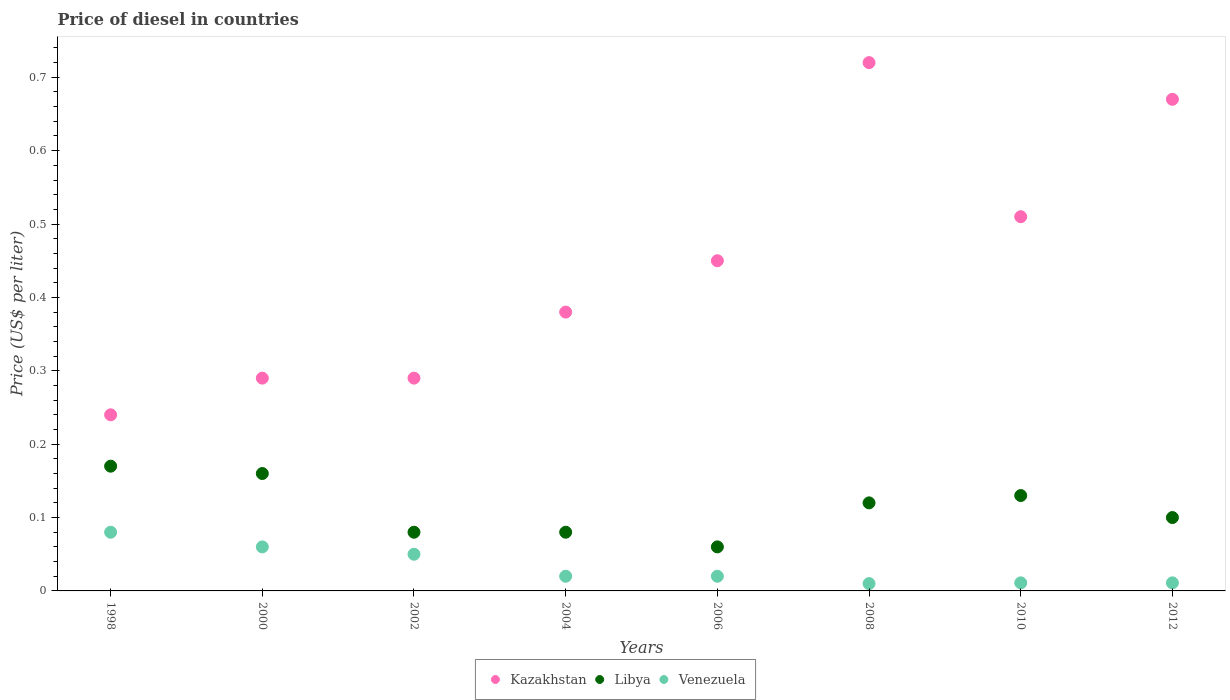How many different coloured dotlines are there?
Provide a succinct answer. 3. Is the number of dotlines equal to the number of legend labels?
Give a very brief answer. Yes. What is the price of diesel in Libya in 2006?
Your response must be concise. 0.06. Across all years, what is the maximum price of diesel in Kazakhstan?
Make the answer very short. 0.72. Across all years, what is the minimum price of diesel in Libya?
Make the answer very short. 0.06. What is the total price of diesel in Venezuela in the graph?
Your answer should be compact. 0.26. What is the difference between the price of diesel in Kazakhstan in 2004 and that in 2008?
Provide a succinct answer. -0.34. What is the difference between the price of diesel in Libya in 2012 and the price of diesel in Venezuela in 2008?
Make the answer very short. 0.09. What is the average price of diesel in Libya per year?
Give a very brief answer. 0.11. In the year 2004, what is the difference between the price of diesel in Kazakhstan and price of diesel in Libya?
Offer a very short reply. 0.3. In how many years, is the price of diesel in Venezuela greater than 0.46 US$?
Ensure brevity in your answer.  0. What is the ratio of the price of diesel in Kazakhstan in 1998 to that in 2002?
Ensure brevity in your answer.  0.83. What is the difference between the highest and the second highest price of diesel in Kazakhstan?
Your response must be concise. 0.05. What is the difference between the highest and the lowest price of diesel in Venezuela?
Your answer should be very brief. 0.07. Is the price of diesel in Kazakhstan strictly less than the price of diesel in Libya over the years?
Give a very brief answer. No. How many dotlines are there?
Give a very brief answer. 3. How many years are there in the graph?
Offer a terse response. 8. Does the graph contain any zero values?
Ensure brevity in your answer.  No. Where does the legend appear in the graph?
Make the answer very short. Bottom center. What is the title of the graph?
Make the answer very short. Price of diesel in countries. What is the label or title of the Y-axis?
Provide a succinct answer. Price (US$ per liter). What is the Price (US$ per liter) of Kazakhstan in 1998?
Your response must be concise. 0.24. What is the Price (US$ per liter) of Libya in 1998?
Provide a short and direct response. 0.17. What is the Price (US$ per liter) of Venezuela in 1998?
Offer a terse response. 0.08. What is the Price (US$ per liter) in Kazakhstan in 2000?
Offer a very short reply. 0.29. What is the Price (US$ per liter) of Libya in 2000?
Offer a very short reply. 0.16. What is the Price (US$ per liter) of Venezuela in 2000?
Offer a terse response. 0.06. What is the Price (US$ per liter) in Kazakhstan in 2002?
Your answer should be very brief. 0.29. What is the Price (US$ per liter) in Kazakhstan in 2004?
Give a very brief answer. 0.38. What is the Price (US$ per liter) in Libya in 2004?
Your answer should be compact. 0.08. What is the Price (US$ per liter) of Kazakhstan in 2006?
Your response must be concise. 0.45. What is the Price (US$ per liter) in Libya in 2006?
Ensure brevity in your answer.  0.06. What is the Price (US$ per liter) in Venezuela in 2006?
Make the answer very short. 0.02. What is the Price (US$ per liter) of Kazakhstan in 2008?
Offer a terse response. 0.72. What is the Price (US$ per liter) in Libya in 2008?
Give a very brief answer. 0.12. What is the Price (US$ per liter) of Kazakhstan in 2010?
Offer a terse response. 0.51. What is the Price (US$ per liter) in Libya in 2010?
Your response must be concise. 0.13. What is the Price (US$ per liter) in Venezuela in 2010?
Provide a succinct answer. 0.01. What is the Price (US$ per liter) of Kazakhstan in 2012?
Your answer should be very brief. 0.67. What is the Price (US$ per liter) in Libya in 2012?
Your answer should be very brief. 0.1. What is the Price (US$ per liter) in Venezuela in 2012?
Offer a terse response. 0.01. Across all years, what is the maximum Price (US$ per liter) in Kazakhstan?
Offer a terse response. 0.72. Across all years, what is the maximum Price (US$ per liter) of Libya?
Provide a short and direct response. 0.17. Across all years, what is the minimum Price (US$ per liter) in Kazakhstan?
Provide a succinct answer. 0.24. What is the total Price (US$ per liter) of Kazakhstan in the graph?
Offer a terse response. 3.55. What is the total Price (US$ per liter) in Libya in the graph?
Give a very brief answer. 0.9. What is the total Price (US$ per liter) of Venezuela in the graph?
Keep it short and to the point. 0.26. What is the difference between the Price (US$ per liter) of Libya in 1998 and that in 2002?
Provide a succinct answer. 0.09. What is the difference between the Price (US$ per liter) in Kazakhstan in 1998 and that in 2004?
Your answer should be very brief. -0.14. What is the difference between the Price (US$ per liter) in Libya in 1998 and that in 2004?
Keep it short and to the point. 0.09. What is the difference between the Price (US$ per liter) in Kazakhstan in 1998 and that in 2006?
Offer a very short reply. -0.21. What is the difference between the Price (US$ per liter) in Libya in 1998 and that in 2006?
Your response must be concise. 0.11. What is the difference between the Price (US$ per liter) of Venezuela in 1998 and that in 2006?
Your response must be concise. 0.06. What is the difference between the Price (US$ per liter) in Kazakhstan in 1998 and that in 2008?
Provide a short and direct response. -0.48. What is the difference between the Price (US$ per liter) in Venezuela in 1998 and that in 2008?
Your response must be concise. 0.07. What is the difference between the Price (US$ per liter) of Kazakhstan in 1998 and that in 2010?
Your answer should be very brief. -0.27. What is the difference between the Price (US$ per liter) of Venezuela in 1998 and that in 2010?
Give a very brief answer. 0.07. What is the difference between the Price (US$ per liter) in Kazakhstan in 1998 and that in 2012?
Your response must be concise. -0.43. What is the difference between the Price (US$ per liter) of Libya in 1998 and that in 2012?
Offer a very short reply. 0.07. What is the difference between the Price (US$ per liter) in Venezuela in 1998 and that in 2012?
Ensure brevity in your answer.  0.07. What is the difference between the Price (US$ per liter) in Libya in 2000 and that in 2002?
Keep it short and to the point. 0.08. What is the difference between the Price (US$ per liter) of Venezuela in 2000 and that in 2002?
Provide a short and direct response. 0.01. What is the difference between the Price (US$ per liter) in Kazakhstan in 2000 and that in 2004?
Your response must be concise. -0.09. What is the difference between the Price (US$ per liter) of Kazakhstan in 2000 and that in 2006?
Ensure brevity in your answer.  -0.16. What is the difference between the Price (US$ per liter) in Libya in 2000 and that in 2006?
Provide a succinct answer. 0.1. What is the difference between the Price (US$ per liter) in Venezuela in 2000 and that in 2006?
Your response must be concise. 0.04. What is the difference between the Price (US$ per liter) of Kazakhstan in 2000 and that in 2008?
Provide a short and direct response. -0.43. What is the difference between the Price (US$ per liter) of Libya in 2000 and that in 2008?
Your answer should be compact. 0.04. What is the difference between the Price (US$ per liter) in Venezuela in 2000 and that in 2008?
Your response must be concise. 0.05. What is the difference between the Price (US$ per liter) in Kazakhstan in 2000 and that in 2010?
Keep it short and to the point. -0.22. What is the difference between the Price (US$ per liter) in Libya in 2000 and that in 2010?
Your answer should be compact. 0.03. What is the difference between the Price (US$ per liter) in Venezuela in 2000 and that in 2010?
Provide a succinct answer. 0.05. What is the difference between the Price (US$ per liter) of Kazakhstan in 2000 and that in 2012?
Your answer should be very brief. -0.38. What is the difference between the Price (US$ per liter) of Venezuela in 2000 and that in 2012?
Your response must be concise. 0.05. What is the difference between the Price (US$ per liter) in Kazakhstan in 2002 and that in 2004?
Make the answer very short. -0.09. What is the difference between the Price (US$ per liter) of Libya in 2002 and that in 2004?
Ensure brevity in your answer.  0. What is the difference between the Price (US$ per liter) in Kazakhstan in 2002 and that in 2006?
Ensure brevity in your answer.  -0.16. What is the difference between the Price (US$ per liter) in Kazakhstan in 2002 and that in 2008?
Keep it short and to the point. -0.43. What is the difference between the Price (US$ per liter) of Libya in 2002 and that in 2008?
Give a very brief answer. -0.04. What is the difference between the Price (US$ per liter) in Kazakhstan in 2002 and that in 2010?
Provide a succinct answer. -0.22. What is the difference between the Price (US$ per liter) of Libya in 2002 and that in 2010?
Ensure brevity in your answer.  -0.05. What is the difference between the Price (US$ per liter) in Venezuela in 2002 and that in 2010?
Your response must be concise. 0.04. What is the difference between the Price (US$ per liter) in Kazakhstan in 2002 and that in 2012?
Give a very brief answer. -0.38. What is the difference between the Price (US$ per liter) in Libya in 2002 and that in 2012?
Offer a very short reply. -0.02. What is the difference between the Price (US$ per liter) in Venezuela in 2002 and that in 2012?
Give a very brief answer. 0.04. What is the difference between the Price (US$ per liter) of Kazakhstan in 2004 and that in 2006?
Your answer should be very brief. -0.07. What is the difference between the Price (US$ per liter) in Venezuela in 2004 and that in 2006?
Ensure brevity in your answer.  0. What is the difference between the Price (US$ per liter) of Kazakhstan in 2004 and that in 2008?
Your answer should be compact. -0.34. What is the difference between the Price (US$ per liter) in Libya in 2004 and that in 2008?
Offer a terse response. -0.04. What is the difference between the Price (US$ per liter) of Kazakhstan in 2004 and that in 2010?
Make the answer very short. -0.13. What is the difference between the Price (US$ per liter) of Venezuela in 2004 and that in 2010?
Your answer should be compact. 0.01. What is the difference between the Price (US$ per liter) of Kazakhstan in 2004 and that in 2012?
Offer a very short reply. -0.29. What is the difference between the Price (US$ per liter) in Libya in 2004 and that in 2012?
Offer a very short reply. -0.02. What is the difference between the Price (US$ per liter) in Venezuela in 2004 and that in 2012?
Keep it short and to the point. 0.01. What is the difference between the Price (US$ per liter) of Kazakhstan in 2006 and that in 2008?
Ensure brevity in your answer.  -0.27. What is the difference between the Price (US$ per liter) of Libya in 2006 and that in 2008?
Make the answer very short. -0.06. What is the difference between the Price (US$ per liter) in Venezuela in 2006 and that in 2008?
Provide a short and direct response. 0.01. What is the difference between the Price (US$ per liter) in Kazakhstan in 2006 and that in 2010?
Give a very brief answer. -0.06. What is the difference between the Price (US$ per liter) of Libya in 2006 and that in 2010?
Offer a terse response. -0.07. What is the difference between the Price (US$ per liter) of Venezuela in 2006 and that in 2010?
Offer a terse response. 0.01. What is the difference between the Price (US$ per liter) in Kazakhstan in 2006 and that in 2012?
Offer a terse response. -0.22. What is the difference between the Price (US$ per liter) in Libya in 2006 and that in 2012?
Your answer should be very brief. -0.04. What is the difference between the Price (US$ per liter) of Venezuela in 2006 and that in 2012?
Your response must be concise. 0.01. What is the difference between the Price (US$ per liter) of Kazakhstan in 2008 and that in 2010?
Offer a terse response. 0.21. What is the difference between the Price (US$ per liter) in Libya in 2008 and that in 2010?
Ensure brevity in your answer.  -0.01. What is the difference between the Price (US$ per liter) of Venezuela in 2008 and that in 2010?
Provide a succinct answer. -0. What is the difference between the Price (US$ per liter) of Kazakhstan in 2008 and that in 2012?
Ensure brevity in your answer.  0.05. What is the difference between the Price (US$ per liter) of Libya in 2008 and that in 2012?
Provide a succinct answer. 0.02. What is the difference between the Price (US$ per liter) in Venezuela in 2008 and that in 2012?
Offer a terse response. -0. What is the difference between the Price (US$ per liter) of Kazakhstan in 2010 and that in 2012?
Give a very brief answer. -0.16. What is the difference between the Price (US$ per liter) of Libya in 2010 and that in 2012?
Ensure brevity in your answer.  0.03. What is the difference between the Price (US$ per liter) in Venezuela in 2010 and that in 2012?
Make the answer very short. 0. What is the difference between the Price (US$ per liter) in Kazakhstan in 1998 and the Price (US$ per liter) in Venezuela in 2000?
Provide a short and direct response. 0.18. What is the difference between the Price (US$ per liter) in Libya in 1998 and the Price (US$ per liter) in Venezuela in 2000?
Your answer should be compact. 0.11. What is the difference between the Price (US$ per liter) of Kazakhstan in 1998 and the Price (US$ per liter) of Libya in 2002?
Make the answer very short. 0.16. What is the difference between the Price (US$ per liter) of Kazakhstan in 1998 and the Price (US$ per liter) of Venezuela in 2002?
Offer a very short reply. 0.19. What is the difference between the Price (US$ per liter) of Libya in 1998 and the Price (US$ per liter) of Venezuela in 2002?
Provide a short and direct response. 0.12. What is the difference between the Price (US$ per liter) of Kazakhstan in 1998 and the Price (US$ per liter) of Libya in 2004?
Make the answer very short. 0.16. What is the difference between the Price (US$ per liter) in Kazakhstan in 1998 and the Price (US$ per liter) in Venezuela in 2004?
Your answer should be very brief. 0.22. What is the difference between the Price (US$ per liter) of Libya in 1998 and the Price (US$ per liter) of Venezuela in 2004?
Offer a very short reply. 0.15. What is the difference between the Price (US$ per liter) of Kazakhstan in 1998 and the Price (US$ per liter) of Libya in 2006?
Provide a succinct answer. 0.18. What is the difference between the Price (US$ per liter) of Kazakhstan in 1998 and the Price (US$ per liter) of Venezuela in 2006?
Keep it short and to the point. 0.22. What is the difference between the Price (US$ per liter) of Libya in 1998 and the Price (US$ per liter) of Venezuela in 2006?
Offer a very short reply. 0.15. What is the difference between the Price (US$ per liter) in Kazakhstan in 1998 and the Price (US$ per liter) in Libya in 2008?
Your answer should be very brief. 0.12. What is the difference between the Price (US$ per liter) of Kazakhstan in 1998 and the Price (US$ per liter) of Venezuela in 2008?
Offer a terse response. 0.23. What is the difference between the Price (US$ per liter) of Libya in 1998 and the Price (US$ per liter) of Venezuela in 2008?
Offer a terse response. 0.16. What is the difference between the Price (US$ per liter) of Kazakhstan in 1998 and the Price (US$ per liter) of Libya in 2010?
Offer a very short reply. 0.11. What is the difference between the Price (US$ per liter) in Kazakhstan in 1998 and the Price (US$ per liter) in Venezuela in 2010?
Make the answer very short. 0.23. What is the difference between the Price (US$ per liter) of Libya in 1998 and the Price (US$ per liter) of Venezuela in 2010?
Provide a succinct answer. 0.16. What is the difference between the Price (US$ per liter) in Kazakhstan in 1998 and the Price (US$ per liter) in Libya in 2012?
Keep it short and to the point. 0.14. What is the difference between the Price (US$ per liter) in Kazakhstan in 1998 and the Price (US$ per liter) in Venezuela in 2012?
Ensure brevity in your answer.  0.23. What is the difference between the Price (US$ per liter) of Libya in 1998 and the Price (US$ per liter) of Venezuela in 2012?
Ensure brevity in your answer.  0.16. What is the difference between the Price (US$ per liter) of Kazakhstan in 2000 and the Price (US$ per liter) of Libya in 2002?
Give a very brief answer. 0.21. What is the difference between the Price (US$ per liter) of Kazakhstan in 2000 and the Price (US$ per liter) of Venezuela in 2002?
Offer a terse response. 0.24. What is the difference between the Price (US$ per liter) in Libya in 2000 and the Price (US$ per liter) in Venezuela in 2002?
Your answer should be compact. 0.11. What is the difference between the Price (US$ per liter) in Kazakhstan in 2000 and the Price (US$ per liter) in Libya in 2004?
Give a very brief answer. 0.21. What is the difference between the Price (US$ per liter) of Kazakhstan in 2000 and the Price (US$ per liter) of Venezuela in 2004?
Make the answer very short. 0.27. What is the difference between the Price (US$ per liter) of Libya in 2000 and the Price (US$ per liter) of Venezuela in 2004?
Provide a succinct answer. 0.14. What is the difference between the Price (US$ per liter) in Kazakhstan in 2000 and the Price (US$ per liter) in Libya in 2006?
Give a very brief answer. 0.23. What is the difference between the Price (US$ per liter) in Kazakhstan in 2000 and the Price (US$ per liter) in Venezuela in 2006?
Make the answer very short. 0.27. What is the difference between the Price (US$ per liter) in Libya in 2000 and the Price (US$ per liter) in Venezuela in 2006?
Offer a terse response. 0.14. What is the difference between the Price (US$ per liter) in Kazakhstan in 2000 and the Price (US$ per liter) in Libya in 2008?
Offer a very short reply. 0.17. What is the difference between the Price (US$ per liter) in Kazakhstan in 2000 and the Price (US$ per liter) in Venezuela in 2008?
Your answer should be compact. 0.28. What is the difference between the Price (US$ per liter) in Kazakhstan in 2000 and the Price (US$ per liter) in Libya in 2010?
Your answer should be compact. 0.16. What is the difference between the Price (US$ per liter) in Kazakhstan in 2000 and the Price (US$ per liter) in Venezuela in 2010?
Provide a succinct answer. 0.28. What is the difference between the Price (US$ per liter) in Libya in 2000 and the Price (US$ per liter) in Venezuela in 2010?
Your response must be concise. 0.15. What is the difference between the Price (US$ per liter) of Kazakhstan in 2000 and the Price (US$ per liter) of Libya in 2012?
Your answer should be compact. 0.19. What is the difference between the Price (US$ per liter) of Kazakhstan in 2000 and the Price (US$ per liter) of Venezuela in 2012?
Offer a very short reply. 0.28. What is the difference between the Price (US$ per liter) in Libya in 2000 and the Price (US$ per liter) in Venezuela in 2012?
Offer a very short reply. 0.15. What is the difference between the Price (US$ per liter) of Kazakhstan in 2002 and the Price (US$ per liter) of Libya in 2004?
Make the answer very short. 0.21. What is the difference between the Price (US$ per liter) in Kazakhstan in 2002 and the Price (US$ per liter) in Venezuela in 2004?
Ensure brevity in your answer.  0.27. What is the difference between the Price (US$ per liter) in Kazakhstan in 2002 and the Price (US$ per liter) in Libya in 2006?
Ensure brevity in your answer.  0.23. What is the difference between the Price (US$ per liter) of Kazakhstan in 2002 and the Price (US$ per liter) of Venezuela in 2006?
Ensure brevity in your answer.  0.27. What is the difference between the Price (US$ per liter) of Libya in 2002 and the Price (US$ per liter) of Venezuela in 2006?
Ensure brevity in your answer.  0.06. What is the difference between the Price (US$ per liter) of Kazakhstan in 2002 and the Price (US$ per liter) of Libya in 2008?
Your answer should be compact. 0.17. What is the difference between the Price (US$ per liter) in Kazakhstan in 2002 and the Price (US$ per liter) in Venezuela in 2008?
Your response must be concise. 0.28. What is the difference between the Price (US$ per liter) in Libya in 2002 and the Price (US$ per liter) in Venezuela in 2008?
Offer a terse response. 0.07. What is the difference between the Price (US$ per liter) in Kazakhstan in 2002 and the Price (US$ per liter) in Libya in 2010?
Offer a very short reply. 0.16. What is the difference between the Price (US$ per liter) of Kazakhstan in 2002 and the Price (US$ per liter) of Venezuela in 2010?
Keep it short and to the point. 0.28. What is the difference between the Price (US$ per liter) of Libya in 2002 and the Price (US$ per liter) of Venezuela in 2010?
Your response must be concise. 0.07. What is the difference between the Price (US$ per liter) in Kazakhstan in 2002 and the Price (US$ per liter) in Libya in 2012?
Your answer should be very brief. 0.19. What is the difference between the Price (US$ per liter) of Kazakhstan in 2002 and the Price (US$ per liter) of Venezuela in 2012?
Keep it short and to the point. 0.28. What is the difference between the Price (US$ per liter) in Libya in 2002 and the Price (US$ per liter) in Venezuela in 2012?
Your answer should be compact. 0.07. What is the difference between the Price (US$ per liter) of Kazakhstan in 2004 and the Price (US$ per liter) of Libya in 2006?
Ensure brevity in your answer.  0.32. What is the difference between the Price (US$ per liter) of Kazakhstan in 2004 and the Price (US$ per liter) of Venezuela in 2006?
Make the answer very short. 0.36. What is the difference between the Price (US$ per liter) in Libya in 2004 and the Price (US$ per liter) in Venezuela in 2006?
Your answer should be compact. 0.06. What is the difference between the Price (US$ per liter) of Kazakhstan in 2004 and the Price (US$ per liter) of Libya in 2008?
Provide a short and direct response. 0.26. What is the difference between the Price (US$ per liter) of Kazakhstan in 2004 and the Price (US$ per liter) of Venezuela in 2008?
Provide a succinct answer. 0.37. What is the difference between the Price (US$ per liter) of Libya in 2004 and the Price (US$ per liter) of Venezuela in 2008?
Offer a terse response. 0.07. What is the difference between the Price (US$ per liter) in Kazakhstan in 2004 and the Price (US$ per liter) in Libya in 2010?
Offer a very short reply. 0.25. What is the difference between the Price (US$ per liter) in Kazakhstan in 2004 and the Price (US$ per liter) in Venezuela in 2010?
Offer a terse response. 0.37. What is the difference between the Price (US$ per liter) in Libya in 2004 and the Price (US$ per liter) in Venezuela in 2010?
Provide a succinct answer. 0.07. What is the difference between the Price (US$ per liter) of Kazakhstan in 2004 and the Price (US$ per liter) of Libya in 2012?
Offer a very short reply. 0.28. What is the difference between the Price (US$ per liter) of Kazakhstan in 2004 and the Price (US$ per liter) of Venezuela in 2012?
Offer a very short reply. 0.37. What is the difference between the Price (US$ per liter) in Libya in 2004 and the Price (US$ per liter) in Venezuela in 2012?
Your answer should be very brief. 0.07. What is the difference between the Price (US$ per liter) of Kazakhstan in 2006 and the Price (US$ per liter) of Libya in 2008?
Provide a short and direct response. 0.33. What is the difference between the Price (US$ per liter) of Kazakhstan in 2006 and the Price (US$ per liter) of Venezuela in 2008?
Your answer should be very brief. 0.44. What is the difference between the Price (US$ per liter) of Kazakhstan in 2006 and the Price (US$ per liter) of Libya in 2010?
Ensure brevity in your answer.  0.32. What is the difference between the Price (US$ per liter) in Kazakhstan in 2006 and the Price (US$ per liter) in Venezuela in 2010?
Make the answer very short. 0.44. What is the difference between the Price (US$ per liter) in Libya in 2006 and the Price (US$ per liter) in Venezuela in 2010?
Offer a terse response. 0.05. What is the difference between the Price (US$ per liter) in Kazakhstan in 2006 and the Price (US$ per liter) in Venezuela in 2012?
Your answer should be compact. 0.44. What is the difference between the Price (US$ per liter) of Libya in 2006 and the Price (US$ per liter) of Venezuela in 2012?
Offer a terse response. 0.05. What is the difference between the Price (US$ per liter) of Kazakhstan in 2008 and the Price (US$ per liter) of Libya in 2010?
Ensure brevity in your answer.  0.59. What is the difference between the Price (US$ per liter) of Kazakhstan in 2008 and the Price (US$ per liter) of Venezuela in 2010?
Offer a terse response. 0.71. What is the difference between the Price (US$ per liter) in Libya in 2008 and the Price (US$ per liter) in Venezuela in 2010?
Provide a short and direct response. 0.11. What is the difference between the Price (US$ per liter) in Kazakhstan in 2008 and the Price (US$ per liter) in Libya in 2012?
Provide a succinct answer. 0.62. What is the difference between the Price (US$ per liter) of Kazakhstan in 2008 and the Price (US$ per liter) of Venezuela in 2012?
Provide a short and direct response. 0.71. What is the difference between the Price (US$ per liter) of Libya in 2008 and the Price (US$ per liter) of Venezuela in 2012?
Your answer should be very brief. 0.11. What is the difference between the Price (US$ per liter) in Kazakhstan in 2010 and the Price (US$ per liter) in Libya in 2012?
Keep it short and to the point. 0.41. What is the difference between the Price (US$ per liter) of Kazakhstan in 2010 and the Price (US$ per liter) of Venezuela in 2012?
Provide a succinct answer. 0.5. What is the difference between the Price (US$ per liter) in Libya in 2010 and the Price (US$ per liter) in Venezuela in 2012?
Provide a short and direct response. 0.12. What is the average Price (US$ per liter) in Kazakhstan per year?
Offer a terse response. 0.44. What is the average Price (US$ per liter) in Libya per year?
Your answer should be very brief. 0.11. What is the average Price (US$ per liter) in Venezuela per year?
Your answer should be compact. 0.03. In the year 1998, what is the difference between the Price (US$ per liter) of Kazakhstan and Price (US$ per liter) of Libya?
Make the answer very short. 0.07. In the year 1998, what is the difference between the Price (US$ per liter) in Kazakhstan and Price (US$ per liter) in Venezuela?
Provide a succinct answer. 0.16. In the year 1998, what is the difference between the Price (US$ per liter) of Libya and Price (US$ per liter) of Venezuela?
Your response must be concise. 0.09. In the year 2000, what is the difference between the Price (US$ per liter) in Kazakhstan and Price (US$ per liter) in Libya?
Provide a short and direct response. 0.13. In the year 2000, what is the difference between the Price (US$ per liter) in Kazakhstan and Price (US$ per liter) in Venezuela?
Give a very brief answer. 0.23. In the year 2000, what is the difference between the Price (US$ per liter) in Libya and Price (US$ per liter) in Venezuela?
Provide a succinct answer. 0.1. In the year 2002, what is the difference between the Price (US$ per liter) in Kazakhstan and Price (US$ per liter) in Libya?
Your response must be concise. 0.21. In the year 2002, what is the difference between the Price (US$ per liter) in Kazakhstan and Price (US$ per liter) in Venezuela?
Give a very brief answer. 0.24. In the year 2002, what is the difference between the Price (US$ per liter) of Libya and Price (US$ per liter) of Venezuela?
Your response must be concise. 0.03. In the year 2004, what is the difference between the Price (US$ per liter) of Kazakhstan and Price (US$ per liter) of Venezuela?
Your answer should be compact. 0.36. In the year 2006, what is the difference between the Price (US$ per liter) in Kazakhstan and Price (US$ per liter) in Libya?
Provide a succinct answer. 0.39. In the year 2006, what is the difference between the Price (US$ per liter) in Kazakhstan and Price (US$ per liter) in Venezuela?
Provide a short and direct response. 0.43. In the year 2006, what is the difference between the Price (US$ per liter) of Libya and Price (US$ per liter) of Venezuela?
Your answer should be compact. 0.04. In the year 2008, what is the difference between the Price (US$ per liter) of Kazakhstan and Price (US$ per liter) of Venezuela?
Ensure brevity in your answer.  0.71. In the year 2008, what is the difference between the Price (US$ per liter) in Libya and Price (US$ per liter) in Venezuela?
Your answer should be very brief. 0.11. In the year 2010, what is the difference between the Price (US$ per liter) in Kazakhstan and Price (US$ per liter) in Libya?
Provide a succinct answer. 0.38. In the year 2010, what is the difference between the Price (US$ per liter) of Kazakhstan and Price (US$ per liter) of Venezuela?
Provide a succinct answer. 0.5. In the year 2010, what is the difference between the Price (US$ per liter) in Libya and Price (US$ per liter) in Venezuela?
Give a very brief answer. 0.12. In the year 2012, what is the difference between the Price (US$ per liter) in Kazakhstan and Price (US$ per liter) in Libya?
Keep it short and to the point. 0.57. In the year 2012, what is the difference between the Price (US$ per liter) in Kazakhstan and Price (US$ per liter) in Venezuela?
Make the answer very short. 0.66. In the year 2012, what is the difference between the Price (US$ per liter) of Libya and Price (US$ per liter) of Venezuela?
Offer a very short reply. 0.09. What is the ratio of the Price (US$ per liter) of Kazakhstan in 1998 to that in 2000?
Offer a very short reply. 0.83. What is the ratio of the Price (US$ per liter) in Venezuela in 1998 to that in 2000?
Your answer should be very brief. 1.33. What is the ratio of the Price (US$ per liter) in Kazakhstan in 1998 to that in 2002?
Provide a succinct answer. 0.83. What is the ratio of the Price (US$ per liter) of Libya in 1998 to that in 2002?
Ensure brevity in your answer.  2.12. What is the ratio of the Price (US$ per liter) in Kazakhstan in 1998 to that in 2004?
Offer a very short reply. 0.63. What is the ratio of the Price (US$ per liter) of Libya in 1998 to that in 2004?
Make the answer very short. 2.12. What is the ratio of the Price (US$ per liter) of Kazakhstan in 1998 to that in 2006?
Provide a succinct answer. 0.53. What is the ratio of the Price (US$ per liter) of Libya in 1998 to that in 2006?
Ensure brevity in your answer.  2.83. What is the ratio of the Price (US$ per liter) in Libya in 1998 to that in 2008?
Your answer should be compact. 1.42. What is the ratio of the Price (US$ per liter) of Kazakhstan in 1998 to that in 2010?
Offer a very short reply. 0.47. What is the ratio of the Price (US$ per liter) in Libya in 1998 to that in 2010?
Your response must be concise. 1.31. What is the ratio of the Price (US$ per liter) of Venezuela in 1998 to that in 2010?
Offer a very short reply. 7.27. What is the ratio of the Price (US$ per liter) of Kazakhstan in 1998 to that in 2012?
Your answer should be compact. 0.36. What is the ratio of the Price (US$ per liter) in Libya in 1998 to that in 2012?
Your answer should be very brief. 1.7. What is the ratio of the Price (US$ per liter) of Venezuela in 1998 to that in 2012?
Provide a short and direct response. 7.27. What is the ratio of the Price (US$ per liter) in Kazakhstan in 2000 to that in 2002?
Your answer should be very brief. 1. What is the ratio of the Price (US$ per liter) in Libya in 2000 to that in 2002?
Make the answer very short. 2. What is the ratio of the Price (US$ per liter) of Venezuela in 2000 to that in 2002?
Keep it short and to the point. 1.2. What is the ratio of the Price (US$ per liter) in Kazakhstan in 2000 to that in 2004?
Your answer should be compact. 0.76. What is the ratio of the Price (US$ per liter) of Libya in 2000 to that in 2004?
Offer a terse response. 2. What is the ratio of the Price (US$ per liter) in Venezuela in 2000 to that in 2004?
Provide a short and direct response. 3. What is the ratio of the Price (US$ per liter) in Kazakhstan in 2000 to that in 2006?
Keep it short and to the point. 0.64. What is the ratio of the Price (US$ per liter) of Libya in 2000 to that in 2006?
Your answer should be compact. 2.67. What is the ratio of the Price (US$ per liter) in Kazakhstan in 2000 to that in 2008?
Ensure brevity in your answer.  0.4. What is the ratio of the Price (US$ per liter) of Libya in 2000 to that in 2008?
Give a very brief answer. 1.33. What is the ratio of the Price (US$ per liter) of Kazakhstan in 2000 to that in 2010?
Your response must be concise. 0.57. What is the ratio of the Price (US$ per liter) of Libya in 2000 to that in 2010?
Give a very brief answer. 1.23. What is the ratio of the Price (US$ per liter) of Venezuela in 2000 to that in 2010?
Give a very brief answer. 5.45. What is the ratio of the Price (US$ per liter) of Kazakhstan in 2000 to that in 2012?
Ensure brevity in your answer.  0.43. What is the ratio of the Price (US$ per liter) of Libya in 2000 to that in 2012?
Ensure brevity in your answer.  1.6. What is the ratio of the Price (US$ per liter) of Venezuela in 2000 to that in 2012?
Offer a very short reply. 5.45. What is the ratio of the Price (US$ per liter) of Kazakhstan in 2002 to that in 2004?
Provide a succinct answer. 0.76. What is the ratio of the Price (US$ per liter) in Kazakhstan in 2002 to that in 2006?
Your answer should be compact. 0.64. What is the ratio of the Price (US$ per liter) in Venezuela in 2002 to that in 2006?
Make the answer very short. 2.5. What is the ratio of the Price (US$ per liter) in Kazakhstan in 2002 to that in 2008?
Provide a succinct answer. 0.4. What is the ratio of the Price (US$ per liter) of Libya in 2002 to that in 2008?
Provide a succinct answer. 0.67. What is the ratio of the Price (US$ per liter) of Kazakhstan in 2002 to that in 2010?
Your response must be concise. 0.57. What is the ratio of the Price (US$ per liter) of Libya in 2002 to that in 2010?
Provide a short and direct response. 0.62. What is the ratio of the Price (US$ per liter) in Venezuela in 2002 to that in 2010?
Your answer should be compact. 4.55. What is the ratio of the Price (US$ per liter) in Kazakhstan in 2002 to that in 2012?
Your answer should be compact. 0.43. What is the ratio of the Price (US$ per liter) of Venezuela in 2002 to that in 2012?
Provide a short and direct response. 4.55. What is the ratio of the Price (US$ per liter) in Kazakhstan in 2004 to that in 2006?
Offer a very short reply. 0.84. What is the ratio of the Price (US$ per liter) of Venezuela in 2004 to that in 2006?
Offer a very short reply. 1. What is the ratio of the Price (US$ per liter) in Kazakhstan in 2004 to that in 2008?
Provide a short and direct response. 0.53. What is the ratio of the Price (US$ per liter) of Venezuela in 2004 to that in 2008?
Your response must be concise. 2. What is the ratio of the Price (US$ per liter) in Kazakhstan in 2004 to that in 2010?
Provide a short and direct response. 0.75. What is the ratio of the Price (US$ per liter) in Libya in 2004 to that in 2010?
Your response must be concise. 0.62. What is the ratio of the Price (US$ per liter) of Venezuela in 2004 to that in 2010?
Keep it short and to the point. 1.82. What is the ratio of the Price (US$ per liter) of Kazakhstan in 2004 to that in 2012?
Give a very brief answer. 0.57. What is the ratio of the Price (US$ per liter) in Venezuela in 2004 to that in 2012?
Make the answer very short. 1.82. What is the ratio of the Price (US$ per liter) in Libya in 2006 to that in 2008?
Your answer should be compact. 0.5. What is the ratio of the Price (US$ per liter) of Kazakhstan in 2006 to that in 2010?
Offer a very short reply. 0.88. What is the ratio of the Price (US$ per liter) in Libya in 2006 to that in 2010?
Make the answer very short. 0.46. What is the ratio of the Price (US$ per liter) in Venezuela in 2006 to that in 2010?
Your answer should be very brief. 1.82. What is the ratio of the Price (US$ per liter) in Kazakhstan in 2006 to that in 2012?
Offer a terse response. 0.67. What is the ratio of the Price (US$ per liter) in Libya in 2006 to that in 2012?
Give a very brief answer. 0.6. What is the ratio of the Price (US$ per liter) in Venezuela in 2006 to that in 2012?
Your response must be concise. 1.82. What is the ratio of the Price (US$ per liter) of Kazakhstan in 2008 to that in 2010?
Your answer should be compact. 1.41. What is the ratio of the Price (US$ per liter) of Libya in 2008 to that in 2010?
Offer a terse response. 0.92. What is the ratio of the Price (US$ per liter) in Kazakhstan in 2008 to that in 2012?
Provide a succinct answer. 1.07. What is the ratio of the Price (US$ per liter) in Libya in 2008 to that in 2012?
Your answer should be very brief. 1.2. What is the ratio of the Price (US$ per liter) of Venezuela in 2008 to that in 2012?
Make the answer very short. 0.91. What is the ratio of the Price (US$ per liter) in Kazakhstan in 2010 to that in 2012?
Your response must be concise. 0.76. What is the ratio of the Price (US$ per liter) in Libya in 2010 to that in 2012?
Give a very brief answer. 1.3. What is the ratio of the Price (US$ per liter) of Venezuela in 2010 to that in 2012?
Keep it short and to the point. 1. What is the difference between the highest and the second highest Price (US$ per liter) in Venezuela?
Keep it short and to the point. 0.02. What is the difference between the highest and the lowest Price (US$ per liter) of Kazakhstan?
Keep it short and to the point. 0.48. What is the difference between the highest and the lowest Price (US$ per liter) in Libya?
Ensure brevity in your answer.  0.11. What is the difference between the highest and the lowest Price (US$ per liter) in Venezuela?
Provide a succinct answer. 0.07. 